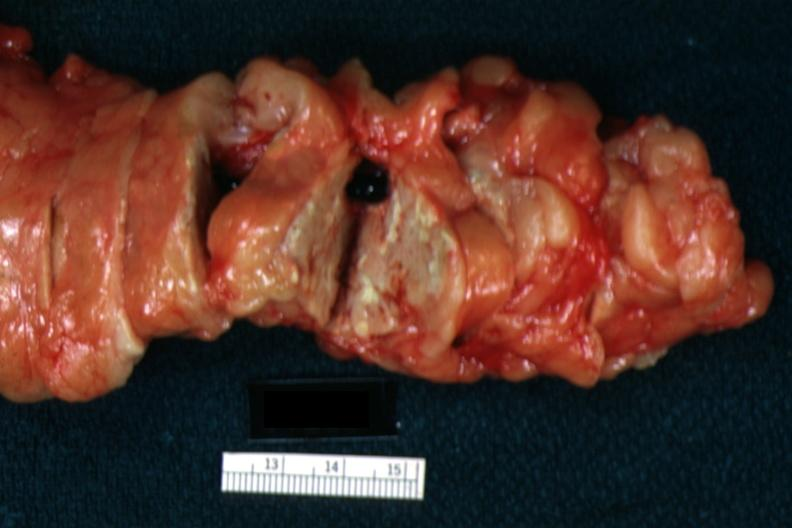what does this image show?
Answer the question using a single word or phrase. Fat necrosis well seen with no evident parenchymal lesion 